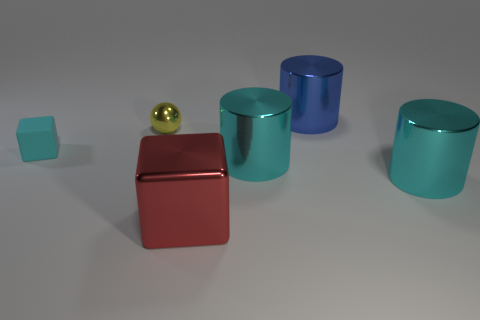Add 3 big red things. How many objects exist? 9 Subtract all balls. How many objects are left? 5 Subtract all tiny green matte objects. Subtract all yellow metallic objects. How many objects are left? 5 Add 6 yellow shiny objects. How many yellow shiny objects are left? 7 Add 5 metallic cubes. How many metallic cubes exist? 6 Subtract 0 gray cylinders. How many objects are left? 6 